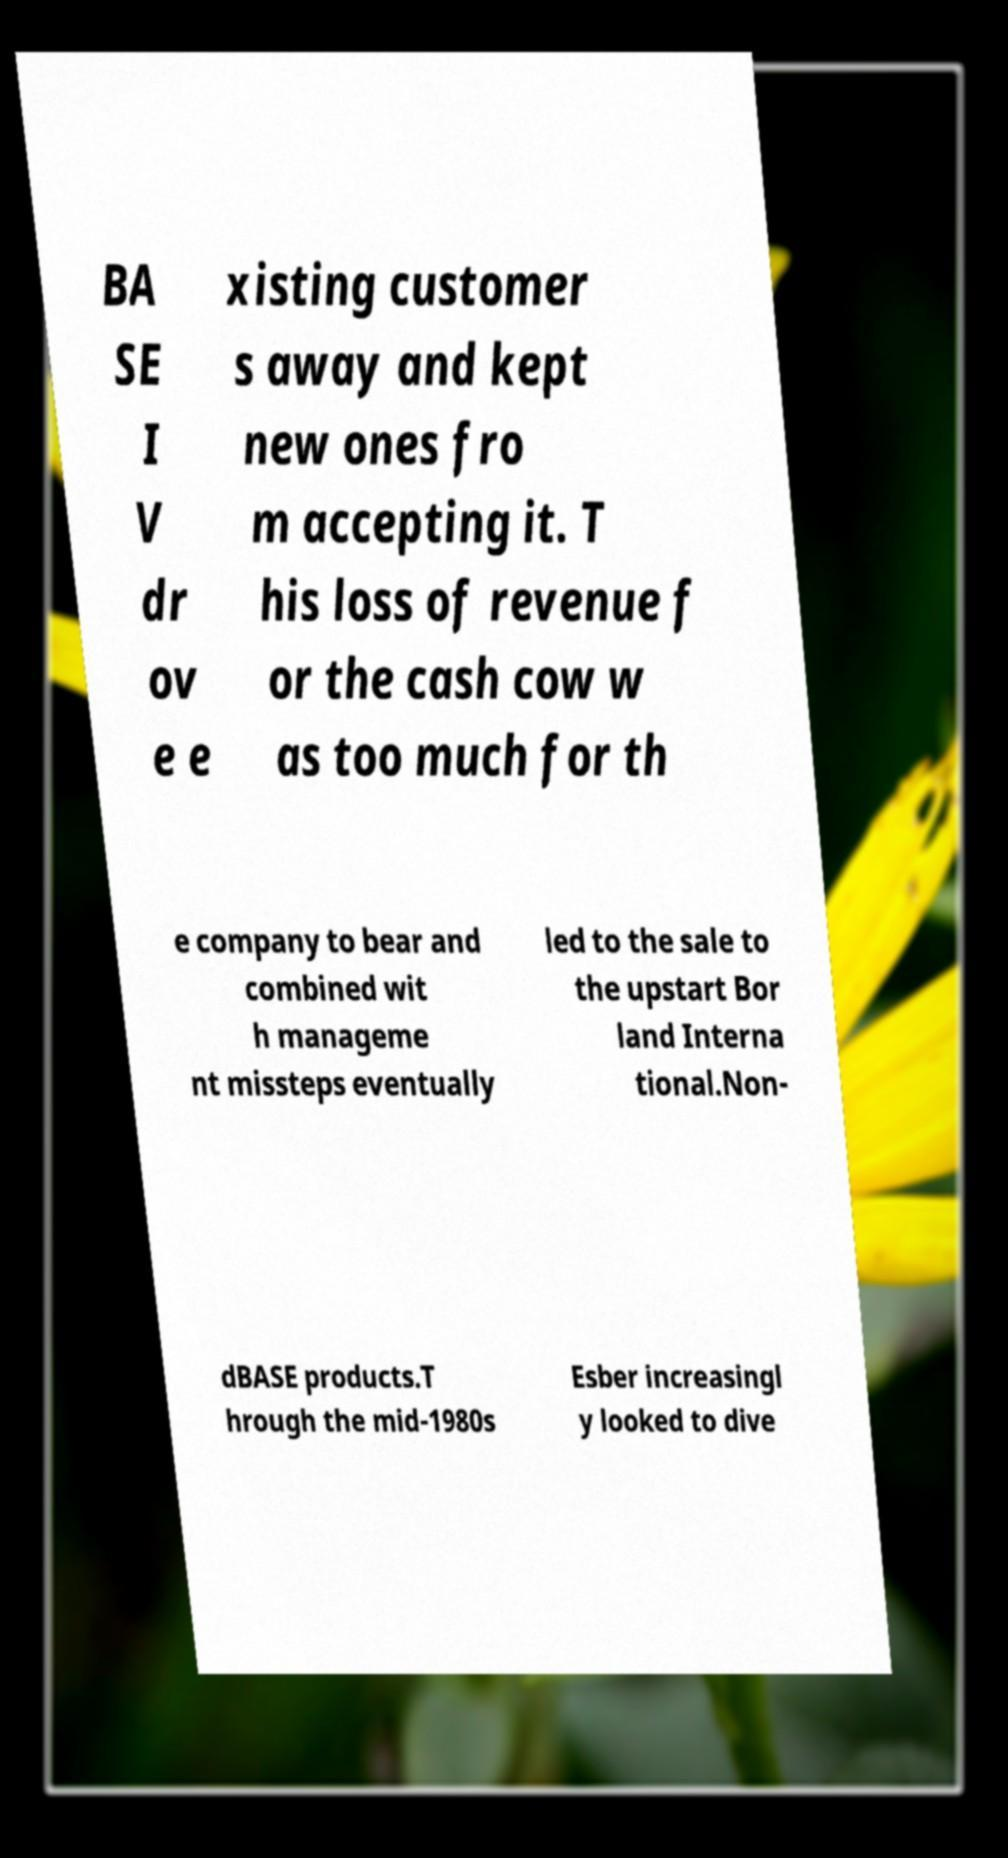Can you read and provide the text displayed in the image?This photo seems to have some interesting text. Can you extract and type it out for me? BA SE I V dr ov e e xisting customer s away and kept new ones fro m accepting it. T his loss of revenue f or the cash cow w as too much for th e company to bear and combined wit h manageme nt missteps eventually led to the sale to the upstart Bor land Interna tional.Non- dBASE products.T hrough the mid-1980s Esber increasingl y looked to dive 